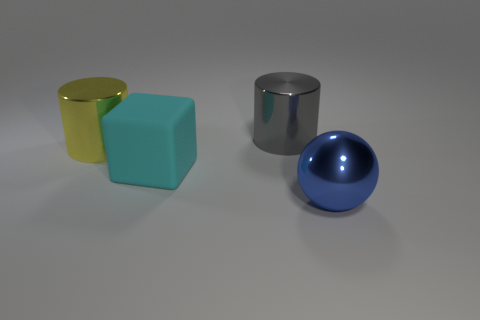Add 3 yellow objects. How many objects exist? 7 Subtract 1 balls. How many balls are left? 0 Subtract all large things. Subtract all tiny gray metal spheres. How many objects are left? 0 Add 1 metallic cylinders. How many metallic cylinders are left? 3 Add 2 small blue metal cylinders. How many small blue metal cylinders exist? 2 Subtract all gray cylinders. How many cylinders are left? 1 Subtract 0 gray spheres. How many objects are left? 4 Subtract all spheres. How many objects are left? 3 Subtract all gray spheres. Subtract all purple cylinders. How many spheres are left? 1 Subtract all red balls. How many green cubes are left? 0 